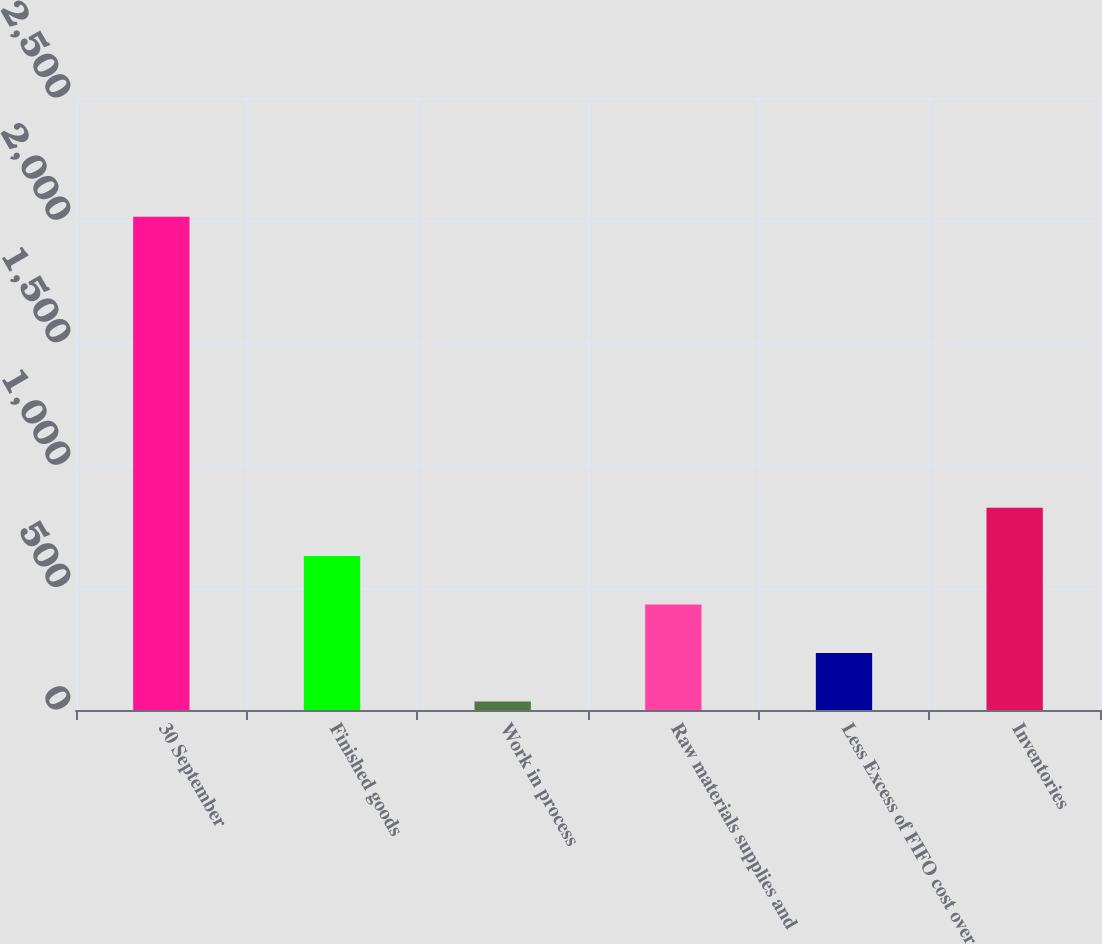<chart> <loc_0><loc_0><loc_500><loc_500><bar_chart><fcel>30 September<fcel>Finished goods<fcel>Work in process<fcel>Raw materials supplies and<fcel>Less Excess of FIFO cost over<fcel>Inventories<nl><fcel>2015<fcel>628.58<fcel>34.4<fcel>430.52<fcel>232.46<fcel>826.64<nl></chart> 